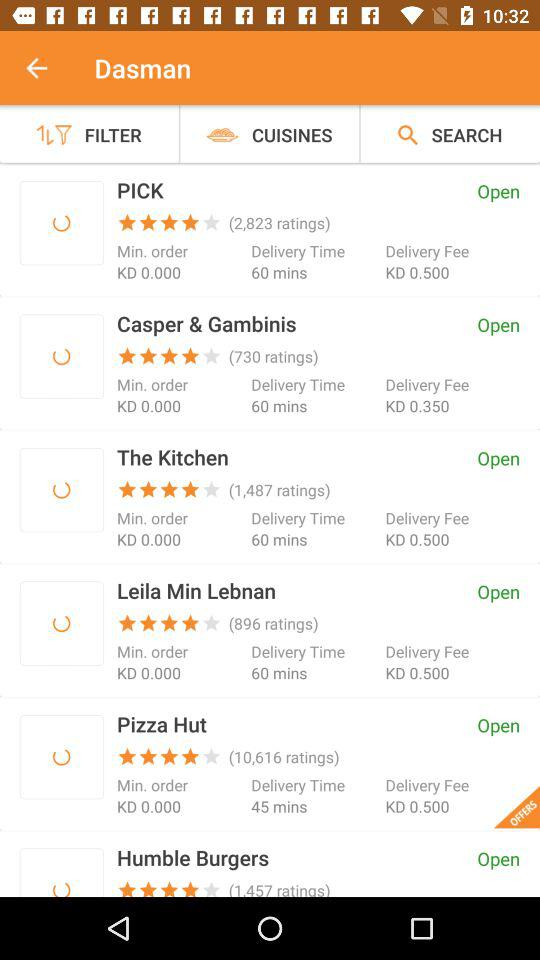How long does "The Kitchen" take for delivery? "The Kitchen" takes 60 minutes for delivery. 